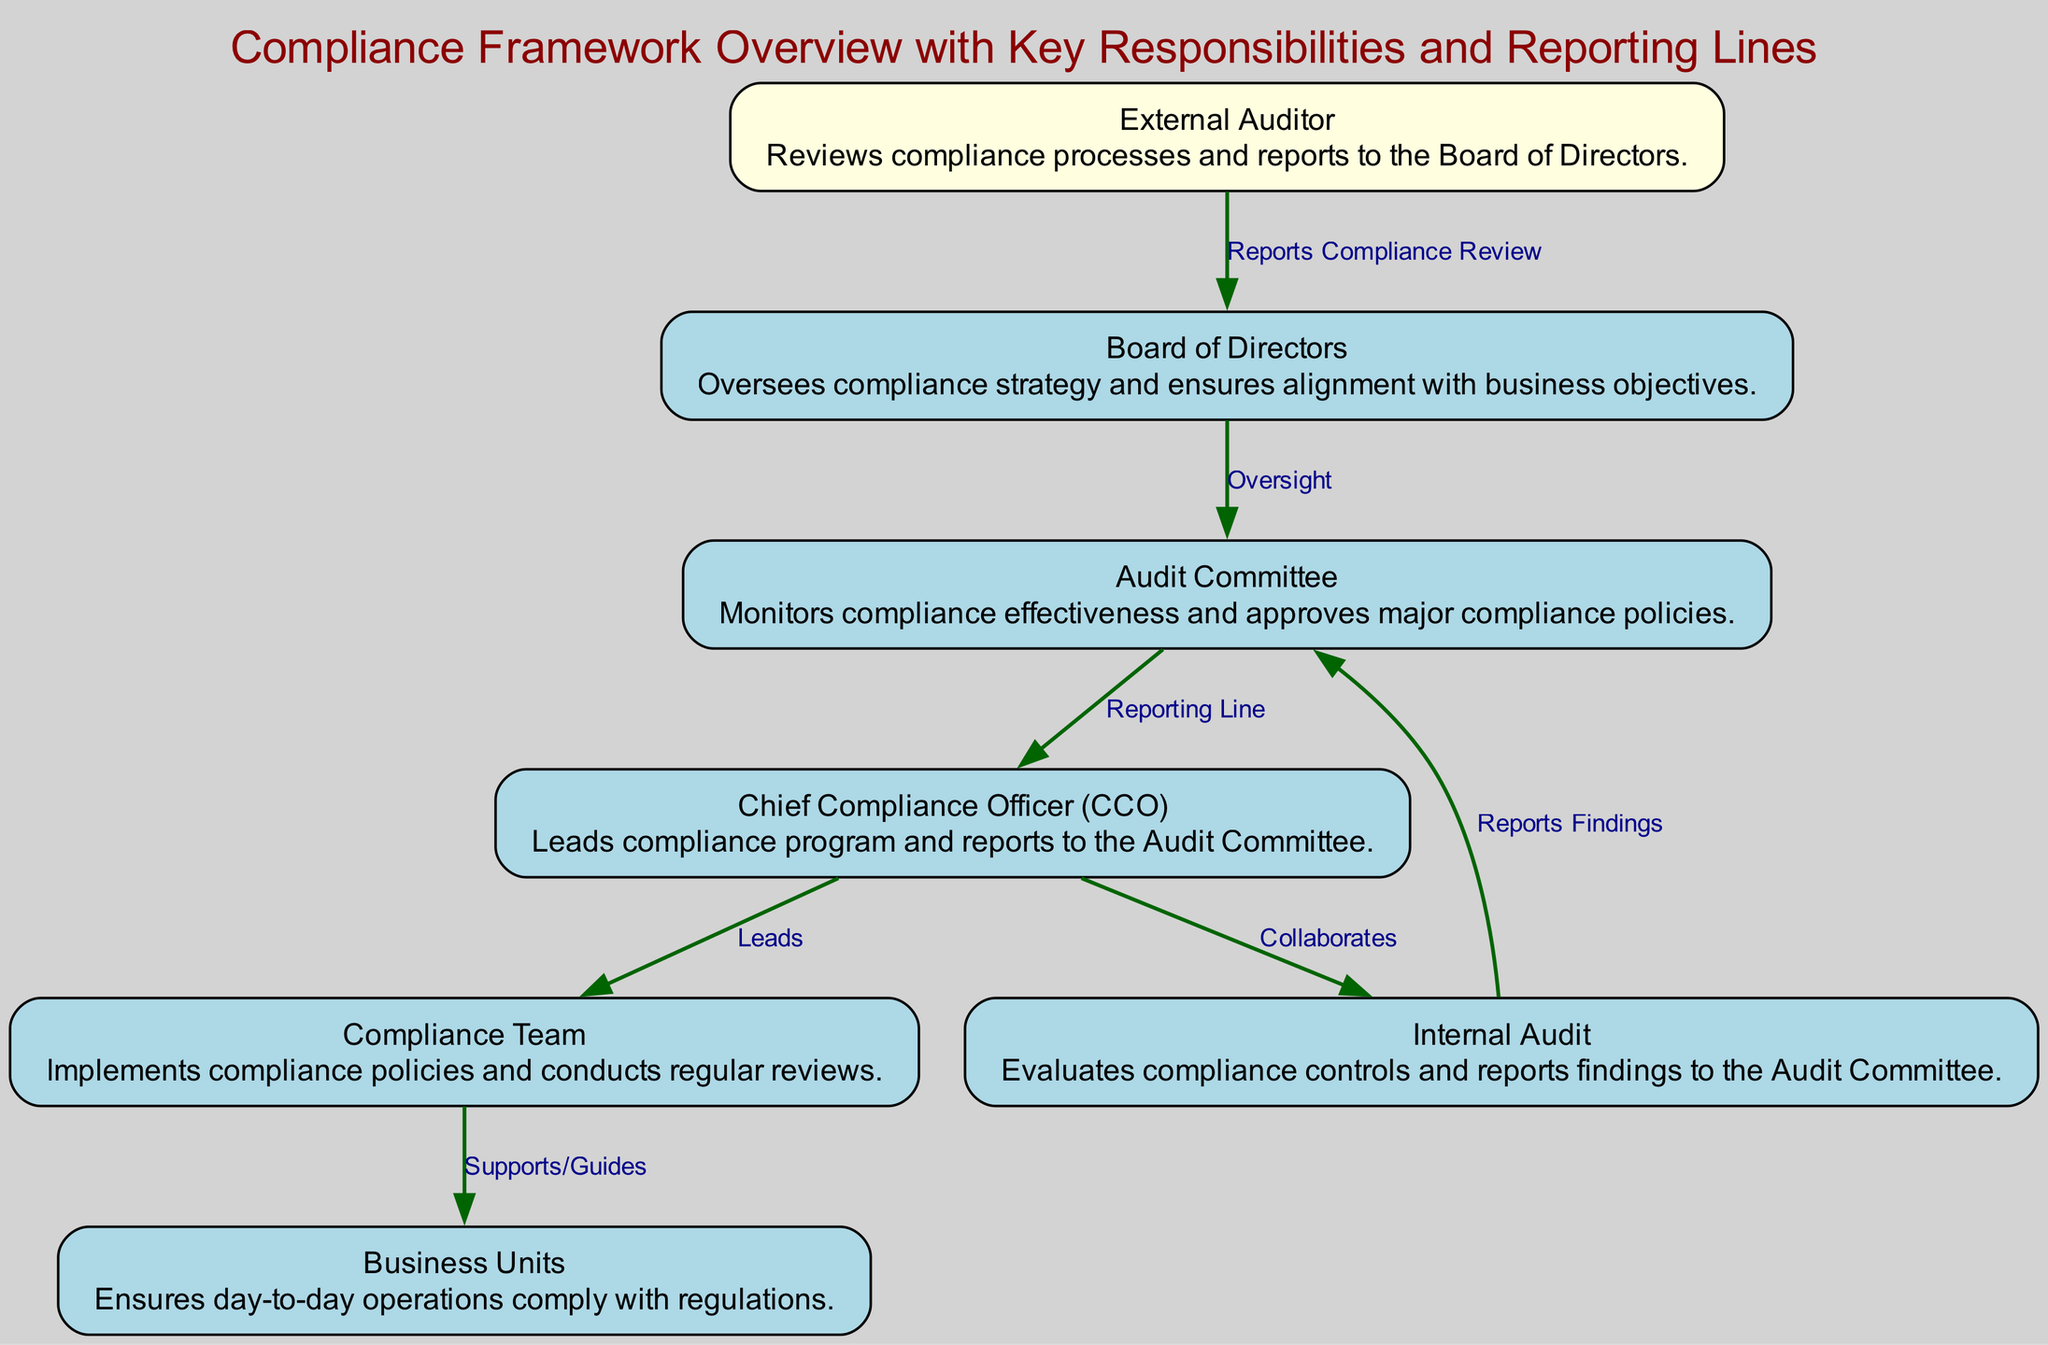What is the top-level governing body in the compliance framework? The diagram indicates that the "Board of Directors" is positioned at the top, which signifies its role as the highest level of oversight in the compliance framework.
Answer: Board of Directors Who does the Chief Compliance Officer report to? According to the diagram, there is a direct edge labeled "Reporting Line" from the "Chief Compliance Officer" to the "Audit Committee," indicating that the CCO reports to the Audit Committee.
Answer: Audit Committee How many nodes are present in this compliance framework diagram? By counting the individual nodes listed (including the Board of Directors, Audit Committee, CCO, Compliance Team, Internal Audit, Business Units, and External Auditor), a total of seven nodes are identified in the diagram.
Answer: 7 What is the role of the Compliance Team? The diagram illustrates that the "Compliance Team" is responsible for "Implementing compliance policies and conducting regular reviews," which is expressed in the details associated with the compliance team node.
Answer: Implements compliance policies and conducts regular reviews Which entities collaborate in the compliance framework? The diagram shows a direct connection labeled "Collaborates" between the "Chief Compliance Officer" and "Internal Audit," indicating a collaborative relationship. This suggests that the CCO works closely with Internal Audit on compliance matters.
Answer: Chief Compliance Officer and Internal Audit Which group provides a report of the compliance review to the Board of Directors? The diagram indicates that the "External Auditor" has a directed edge labeled "Reports Compliance Review" to the "Board of Directors," clearly stating that the External Auditor is responsible for compliance reporting to the board.
Answer: External Auditor What function does the Audit Committee perform in this framework? The Audit Committee is described as "Monitors compliance effectiveness and approves major compliance policies," as shown in its details in the diagram, highlighting its oversight role.
Answer: Monitors compliance effectiveness and approves major compliance policies How does the Compliance Team assist Business Units? The diagram specifies that the "Compliance Team" "Supports/Guides" the "Business Units," indicating that their interaction is focused on providing necessary guidance regarding compliance.
Answer: Supports/Guides What type of audit reports findings to the Audit Committee? The diagram indicates that "Internal Audit" evaluates compliance controls and specifically has a connection labeled "Reports Findings" that goes to the "Audit Committee," identifying it as the reporting entity.
Answer: Internal Audit 